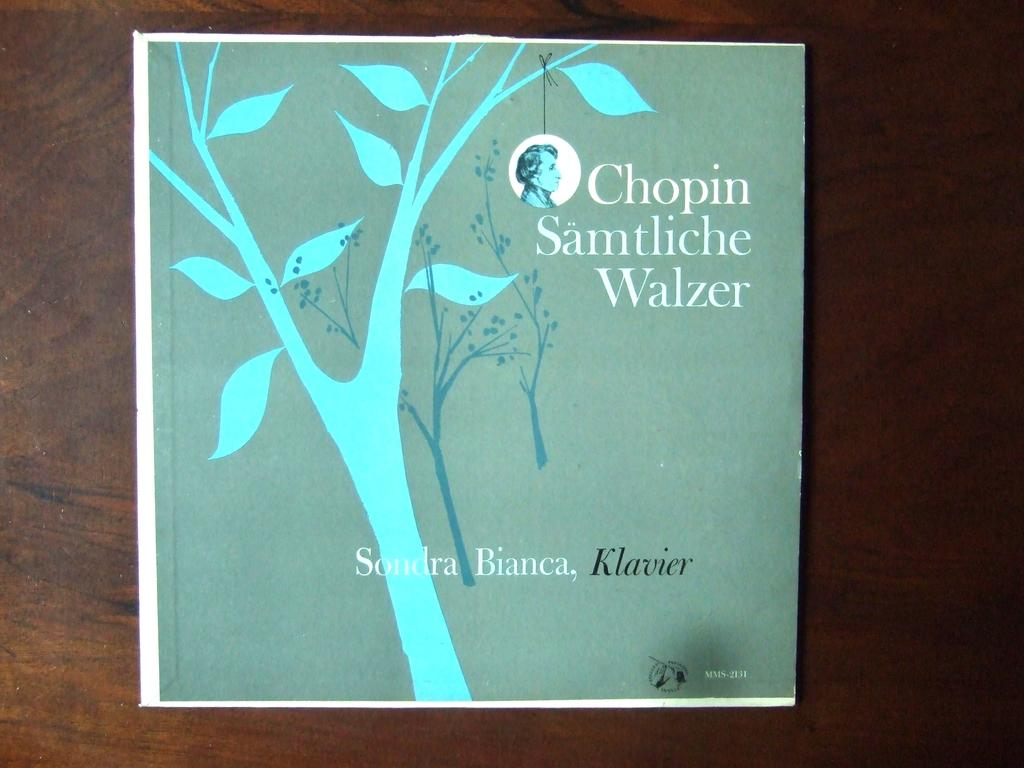What is the color of the surface in the image? The surface in the image is brown. What is placed on the surface? There is a green color poster on the surface. What can be seen on the poster? The poster contains images of trees. Is there any text on the poster? Yes, there is text written on the poster. How many bikes are parked next to the poster in the image? There are no bikes present in the image. What type of pot is shown on the poster? There is no pot shown on the poster; it contains images of trees. 